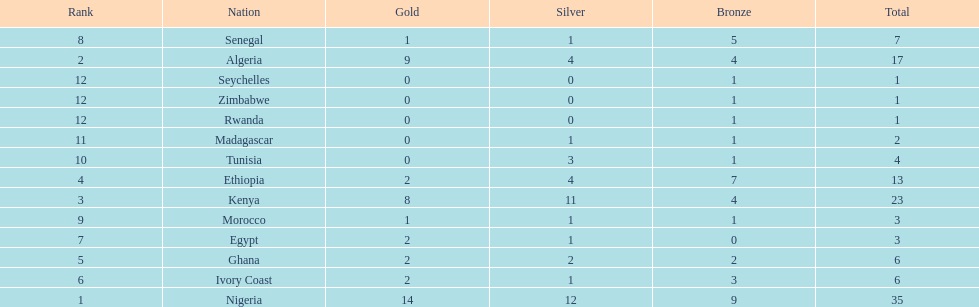Which nations have won only one medal? Rwanda, Zimbabwe, Seychelles. 